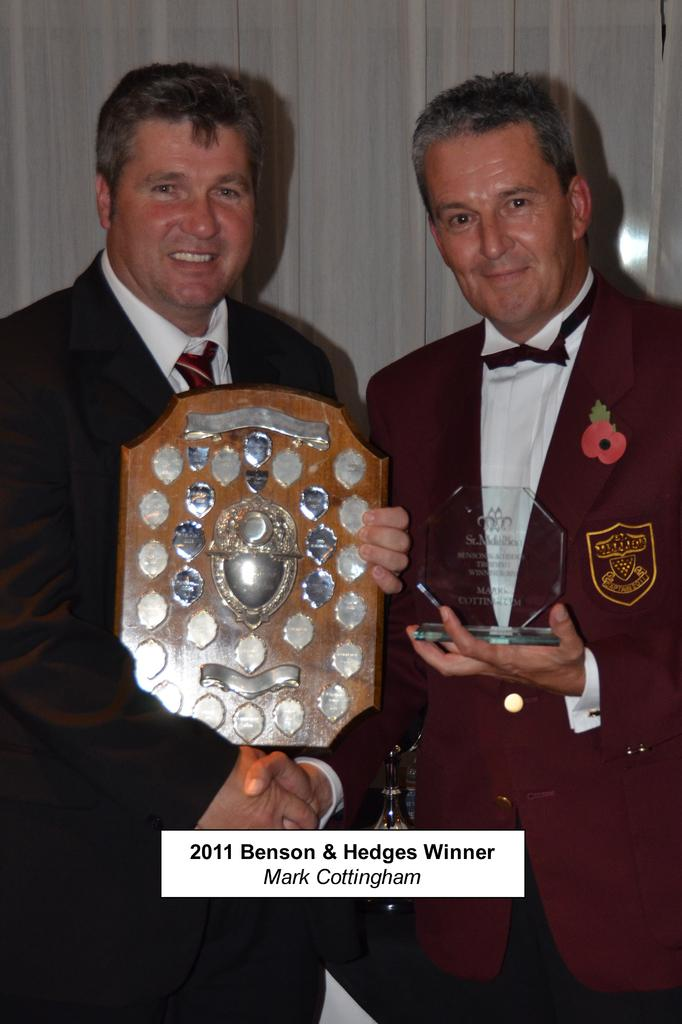How many people are in the image? There are two men in the image. What are the men doing in the image? The men are shaking hands and holding memorandums. What are the men wearing in the image? The men are wearing suits. What can be seen at the bottom of the image? There is text at the bottom of the image. What is visible in the background of the image? There is a curtain in the background of the image. How many cows are visible in the image? There are no cows present in the image. What type of bead is being used to decorate the unit in the image? There is no unit or bead present in the image. 